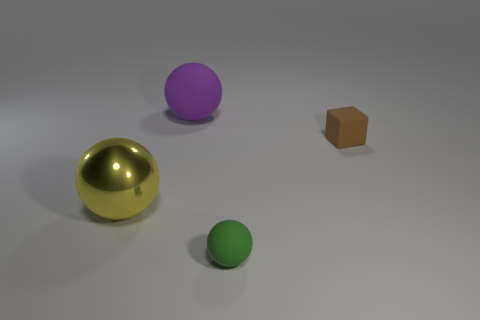Does the metallic object have the same shape as the green rubber object?
Provide a short and direct response. Yes. How many things are small green shiny spheres or balls right of the big yellow metallic thing?
Offer a very short reply. 2. How many brown matte objects are there?
Offer a terse response. 1. Are there any purple metallic cylinders of the same size as the brown rubber thing?
Your response must be concise. No. Is the number of big purple matte things that are behind the purple matte thing less than the number of big metallic balls?
Keep it short and to the point. Yes. Do the yellow sphere and the block have the same size?
Offer a terse response. No. There is a ball that is made of the same material as the green object; what is its size?
Your answer should be compact. Large. What number of rubber balls are the same color as the cube?
Offer a terse response. 0. Is the number of big yellow metallic things that are in front of the small sphere less than the number of large yellow balls behind the brown matte thing?
Offer a very short reply. No. There is a thing that is on the left side of the purple thing; does it have the same shape as the purple matte object?
Provide a short and direct response. Yes. 